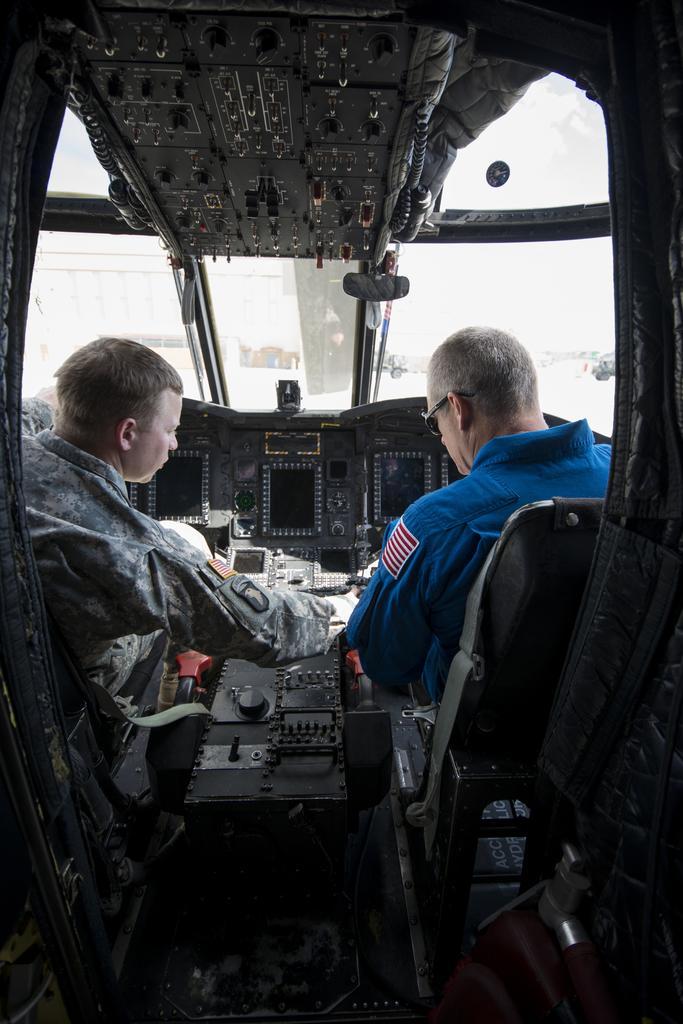Could you give a brief overview of what you see in this image? In the given image i can see the inside view of the aircraft that includes people,chairs and some other objects. 